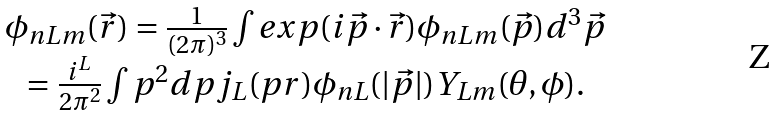Convert formula to latex. <formula><loc_0><loc_0><loc_500><loc_500>\begin{array} { c c c } \phi _ { n L m } ( \vec { r } ) = \frac { 1 } { ( 2 \pi ) ^ { 3 } } \int e x p ( i \vec { p } \cdot \vec { r } ) \phi _ { n L m } ( \vec { p } ) d ^ { 3 } \vec { p } \\ = \frac { i ^ { L } } { 2 \pi ^ { 2 } } \int p ^ { 2 } d p j _ { L } ( p r ) \phi _ { n L } ( | \vec { p } | ) Y _ { L m } ( \theta , \phi ) . \end{array}</formula> 